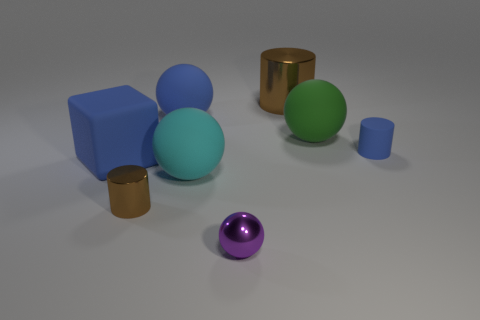Subtract all cyan spheres. How many spheres are left? 3 Subtract 2 cylinders. How many cylinders are left? 1 Subtract all blue cylinders. How many cylinders are left? 2 Add 1 big yellow objects. How many objects exist? 9 Subtract all blocks. How many objects are left? 7 Add 7 big rubber spheres. How many big rubber spheres exist? 10 Subtract 0 yellow cubes. How many objects are left? 8 Subtract all brown balls. Subtract all brown cylinders. How many balls are left? 4 Subtract all purple balls. How many brown blocks are left? 0 Subtract all red cylinders. Subtract all large blue rubber cubes. How many objects are left? 7 